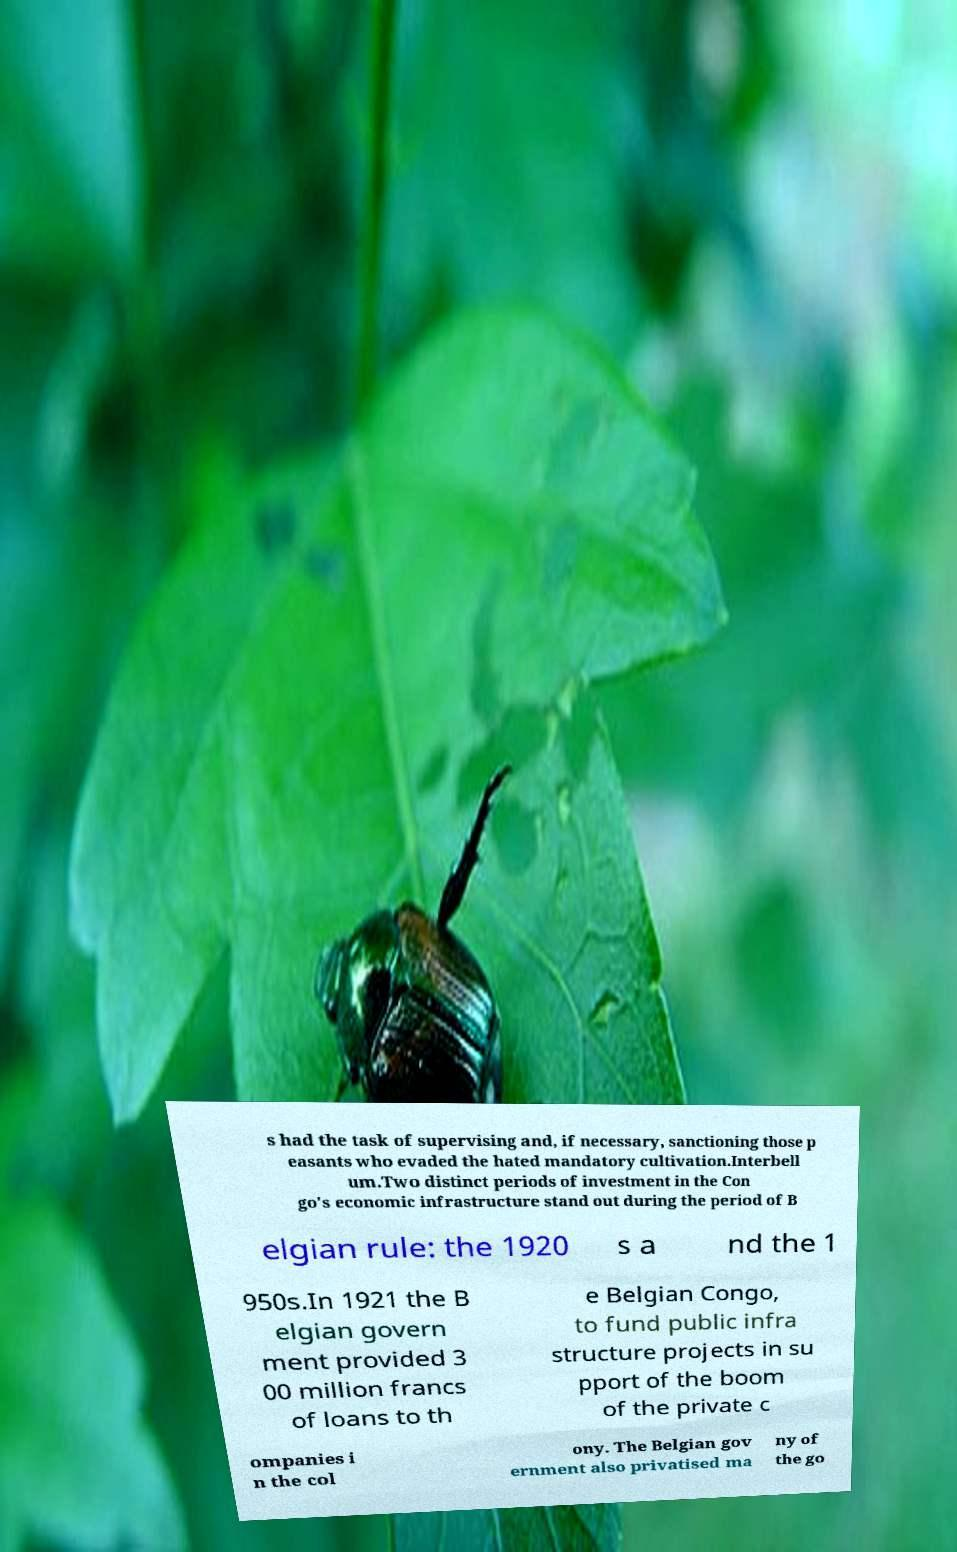There's text embedded in this image that I need extracted. Can you transcribe it verbatim? s had the task of supervising and, if necessary, sanctioning those p easants who evaded the hated mandatory cultivation.Interbell um.Two distinct periods of investment in the Con go's economic infrastructure stand out during the period of B elgian rule: the 1920 s a nd the 1 950s.In 1921 the B elgian govern ment provided 3 00 million francs of loans to th e Belgian Congo, to fund public infra structure projects in su pport of the boom of the private c ompanies i n the col ony. The Belgian gov ernment also privatised ma ny of the go 